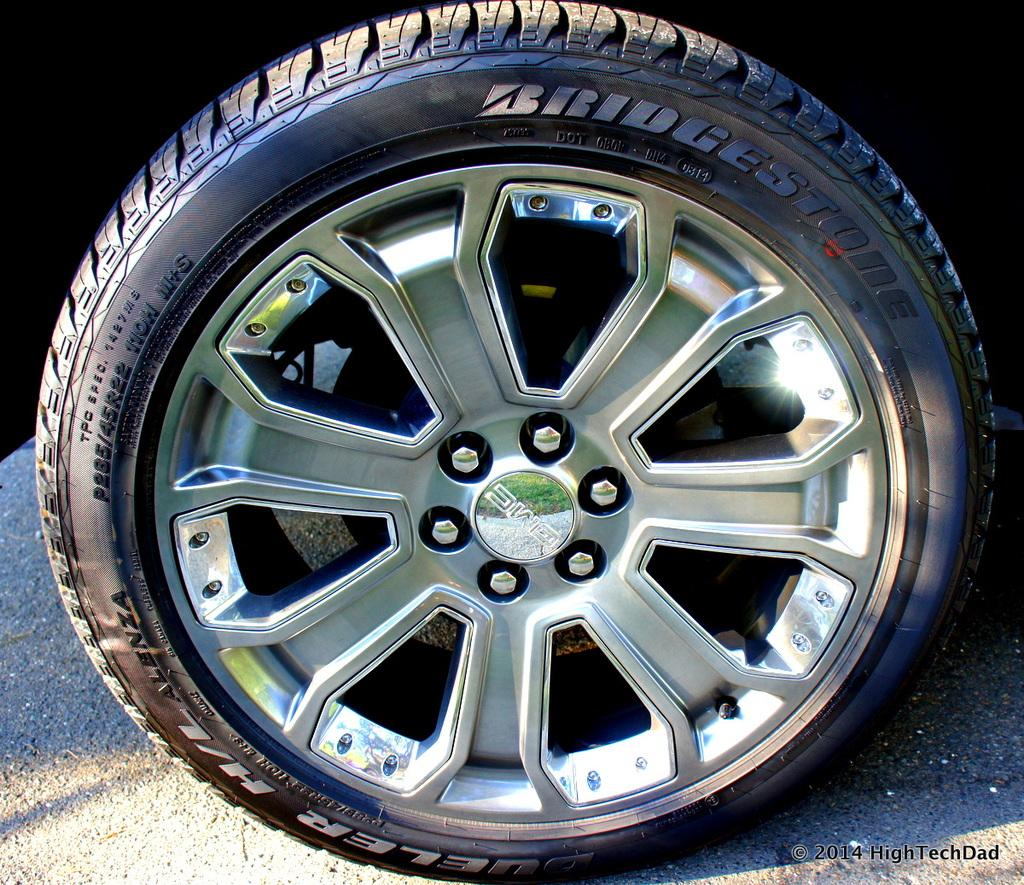What object related to a vehicle can be seen in the image? There is a tire and a wheel of a vehicle in the image. Where are the tire and wheel located? The tire and wheel are on the road in the image. Is there any additional mark or feature on the image? Yes, there is a watermark on the right side of the image. What type of jewel is being held by the crowd in the image? There is no crowd or jewel present in the image; it only features a tire and wheel on the road with a watermark on the right side. 